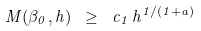Convert formula to latex. <formula><loc_0><loc_0><loc_500><loc_500>M ( \beta _ { 0 } , h ) \ \geq \ c _ { 1 } \, h ^ { 1 / ( 1 + a ) }</formula> 